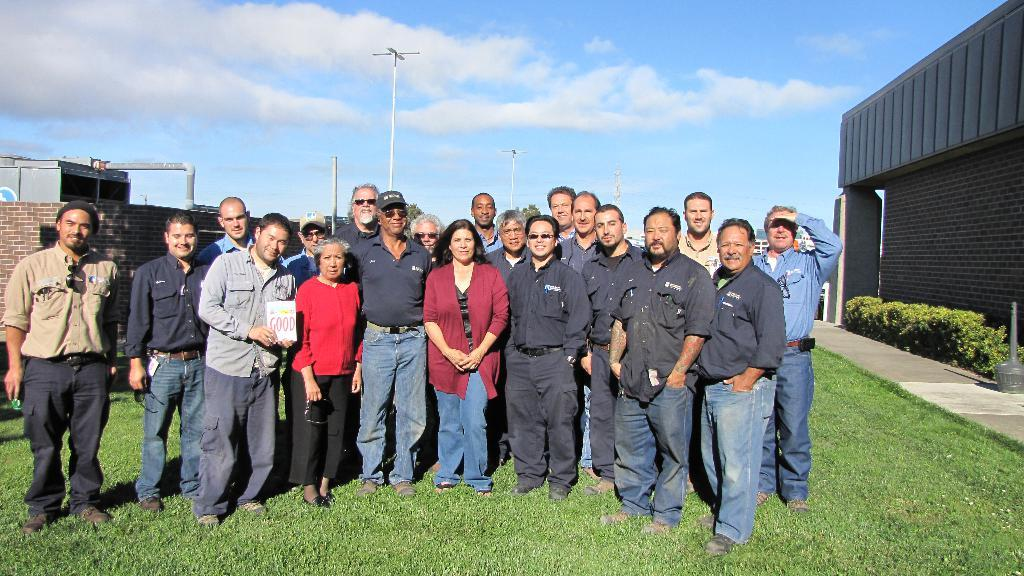How many people are in the image? There is a group of people in the image, but the exact number cannot be determined from the provided facts. What is the position of the people in the image? The people are on the ground in the image. What can be seen in the background of the image? There are buildings, poles, and the sky visible in the background of the image. What type of bone can be seen in the image? There is no bone present in the image. How many fish are swimming in the background of the image? There are no fish visible in the image; it features a group of people on the ground with buildings, poles, and the sky in the background. 